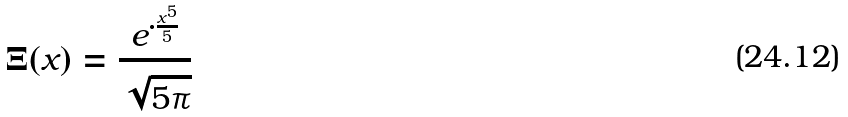Convert formula to latex. <formula><loc_0><loc_0><loc_500><loc_500>\Xi ( x ) = \frac { e ^ { \cdot \frac { x ^ { 5 } } { 5 } } } { \sqrt { 5 \pi } }</formula> 